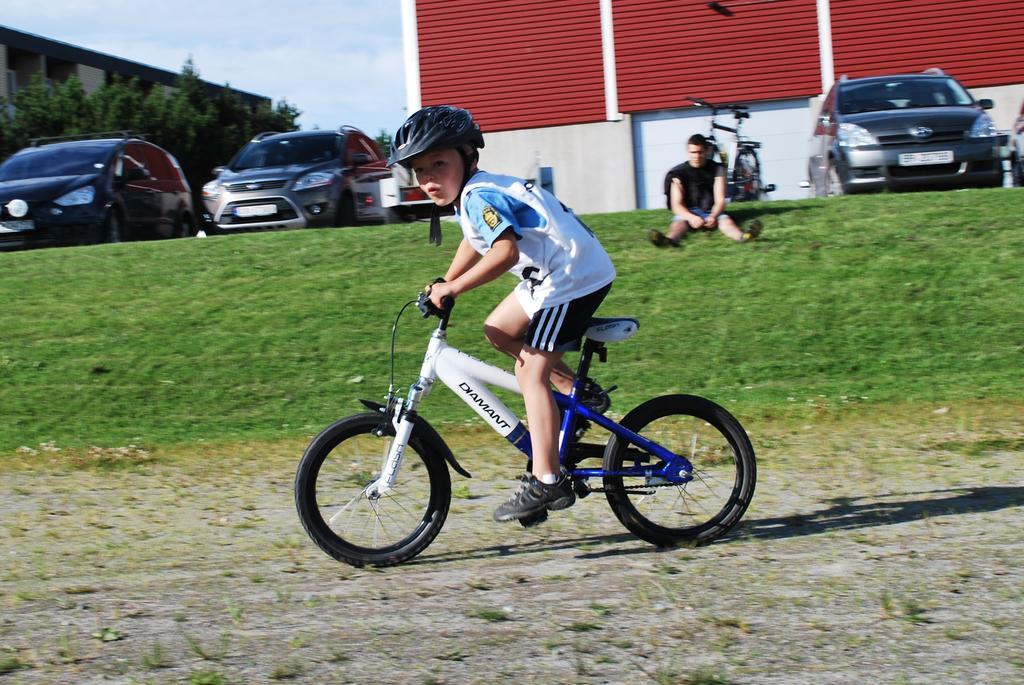Describe this image in one or two sentences. This picture is clicked outside the city. In front of the picture, we see a boy wearing white T-shirt is riding bicycle. Beside him, we see grass and we see man in black t-shirt is sitting in grass. Behind him, we see a building in white and red color and beside that, we see vehicle parked and on the left top of the picture, we see building and trees. 